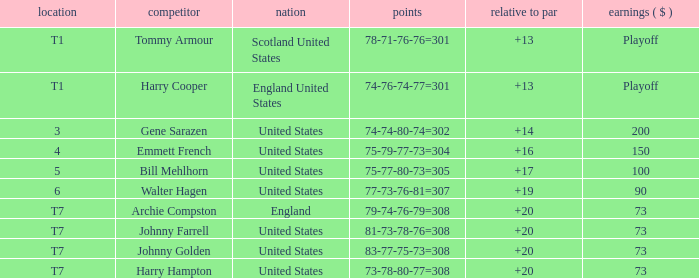What is the ranking when Archie Compston is the player and the money is $73? T7. 